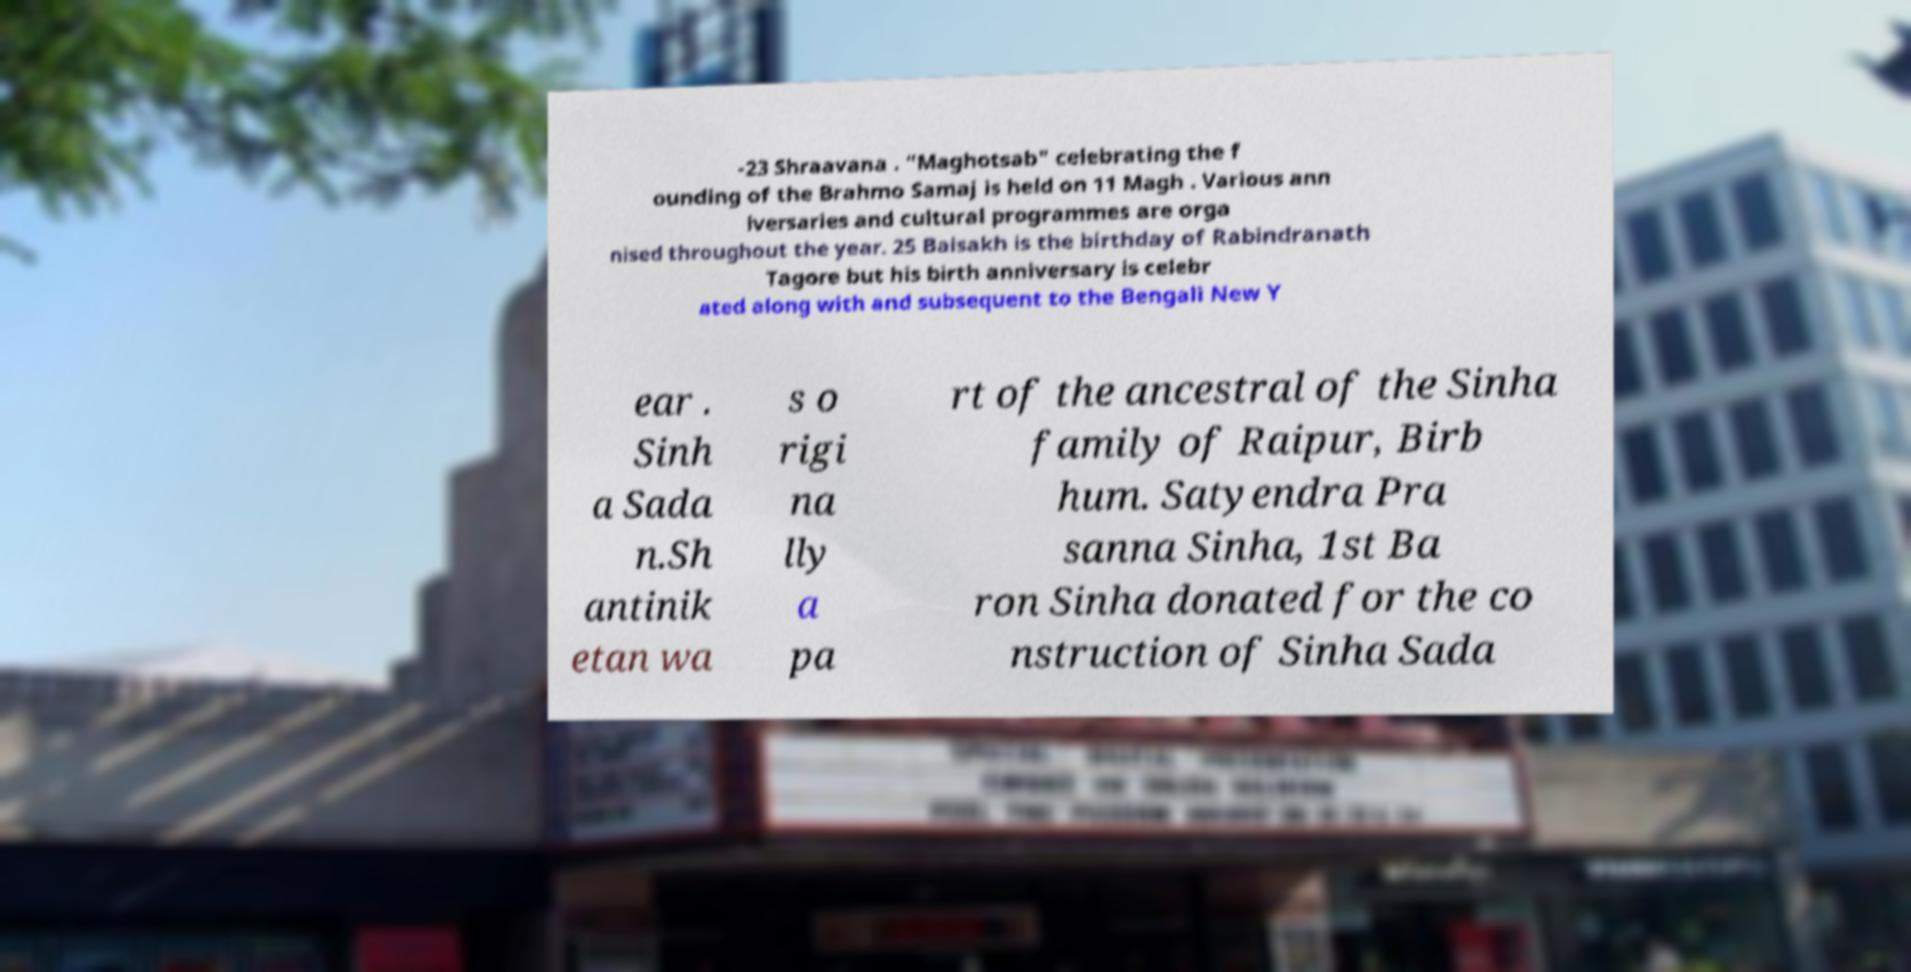Can you accurately transcribe the text from the provided image for me? -23 Shraavana . "Maghotsab" celebrating the f ounding of the Brahmo Samaj is held on 11 Magh . Various ann iversaries and cultural programmes are orga nised throughout the year. 25 Baisakh is the birthday of Rabindranath Tagore but his birth anniversary is celebr ated along with and subsequent to the Bengali New Y ear . Sinh a Sada n.Sh antinik etan wa s o rigi na lly a pa rt of the ancestral of the Sinha family of Raipur, Birb hum. Satyendra Pra sanna Sinha, 1st Ba ron Sinha donated for the co nstruction of Sinha Sada 